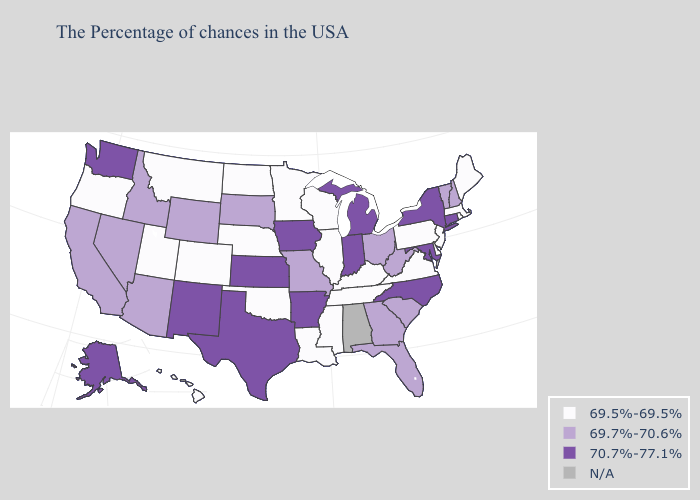Name the states that have a value in the range 69.5%-69.5%?
Be succinct. Maine, Massachusetts, Rhode Island, New Jersey, Delaware, Pennsylvania, Virginia, Kentucky, Tennessee, Wisconsin, Illinois, Mississippi, Louisiana, Minnesota, Nebraska, Oklahoma, North Dakota, Colorado, Utah, Montana, Oregon, Hawaii. Does Arkansas have the lowest value in the South?
Quick response, please. No. Among the states that border Colorado , does Arizona have the highest value?
Write a very short answer. No. Among the states that border Rhode Island , does Connecticut have the highest value?
Quick response, please. Yes. Which states hav the highest value in the Northeast?
Short answer required. Connecticut, New York. Name the states that have a value in the range 69.5%-69.5%?
Be succinct. Maine, Massachusetts, Rhode Island, New Jersey, Delaware, Pennsylvania, Virginia, Kentucky, Tennessee, Wisconsin, Illinois, Mississippi, Louisiana, Minnesota, Nebraska, Oklahoma, North Dakota, Colorado, Utah, Montana, Oregon, Hawaii. Name the states that have a value in the range 69.7%-70.6%?
Quick response, please. New Hampshire, Vermont, South Carolina, West Virginia, Ohio, Florida, Georgia, Missouri, South Dakota, Wyoming, Arizona, Idaho, Nevada, California. Which states have the highest value in the USA?
Quick response, please. Connecticut, New York, Maryland, North Carolina, Michigan, Indiana, Arkansas, Iowa, Kansas, Texas, New Mexico, Washington, Alaska. What is the highest value in the USA?
Write a very short answer. 70.7%-77.1%. Among the states that border Delaware , which have the lowest value?
Concise answer only. New Jersey, Pennsylvania. Does Texas have the highest value in the South?
Short answer required. Yes. Name the states that have a value in the range 70.7%-77.1%?
Concise answer only. Connecticut, New York, Maryland, North Carolina, Michigan, Indiana, Arkansas, Iowa, Kansas, Texas, New Mexico, Washington, Alaska. Which states have the lowest value in the USA?
Be succinct. Maine, Massachusetts, Rhode Island, New Jersey, Delaware, Pennsylvania, Virginia, Kentucky, Tennessee, Wisconsin, Illinois, Mississippi, Louisiana, Minnesota, Nebraska, Oklahoma, North Dakota, Colorado, Utah, Montana, Oregon, Hawaii. Name the states that have a value in the range 69.7%-70.6%?
Quick response, please. New Hampshire, Vermont, South Carolina, West Virginia, Ohio, Florida, Georgia, Missouri, South Dakota, Wyoming, Arizona, Idaho, Nevada, California. Which states have the lowest value in the Northeast?
Quick response, please. Maine, Massachusetts, Rhode Island, New Jersey, Pennsylvania. 